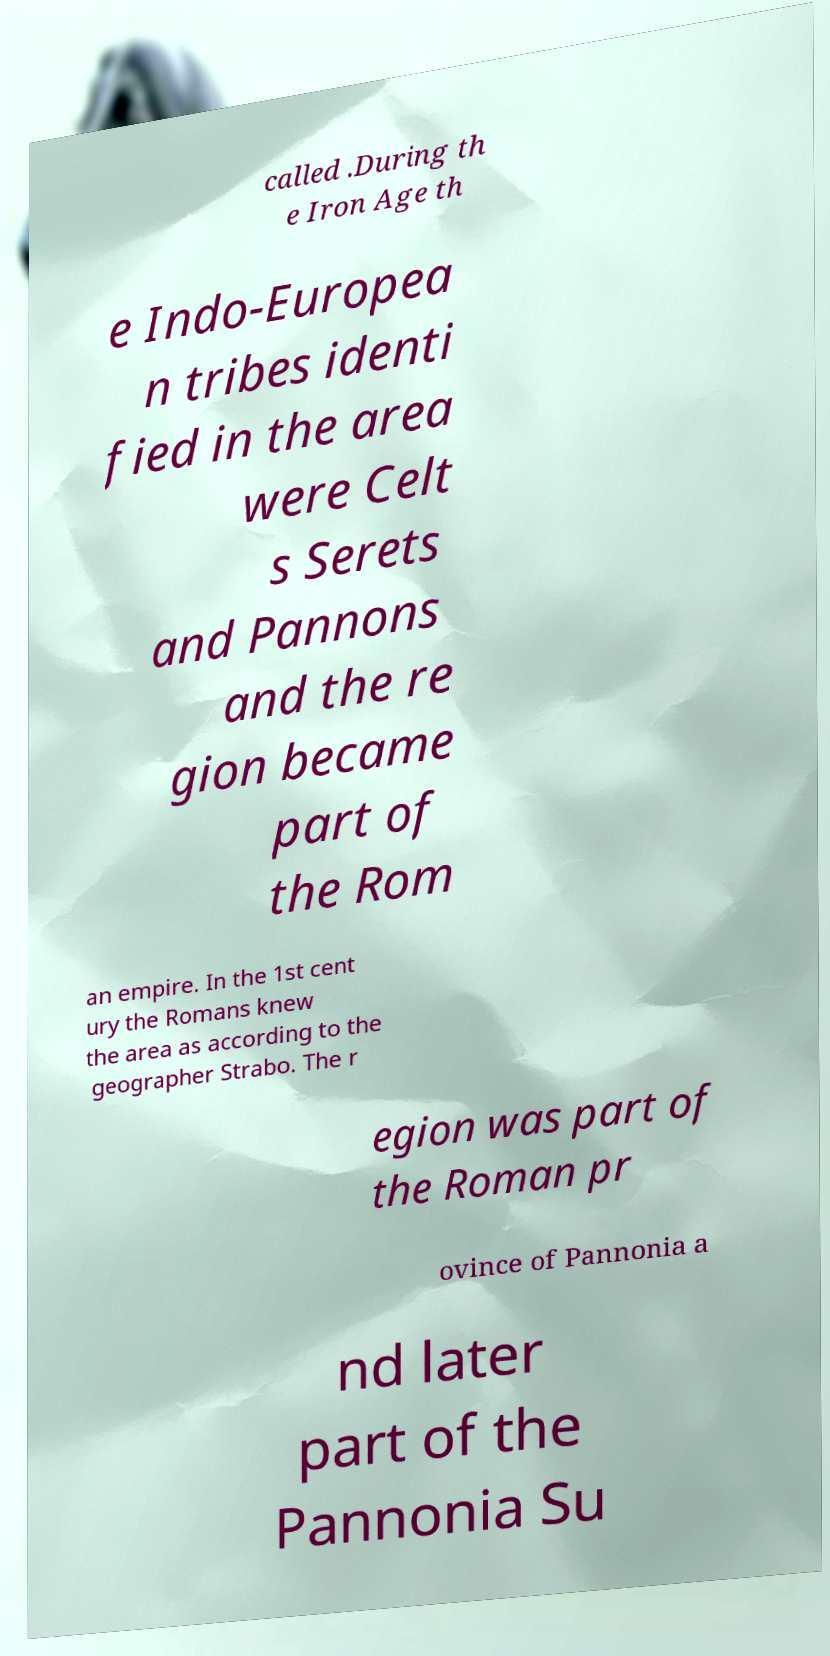Please identify and transcribe the text found in this image. called .During th e Iron Age th e Indo-Europea n tribes identi fied in the area were Celt s Serets and Pannons and the re gion became part of the Rom an empire. In the 1st cent ury the Romans knew the area as according to the geographer Strabo. The r egion was part of the Roman pr ovince of Pannonia a nd later part of the Pannonia Su 